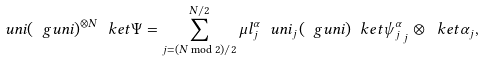<formula> <loc_0><loc_0><loc_500><loc_500>\ u n i ( \ g u n i ) ^ { \otimes N } \ k e t { \Psi } = \sum _ { j = ( N \bmod 2 ) / 2 } ^ { N / 2 } \mu l _ { j } ^ { \alpha } \ u n i _ { j } ( \ g u n i ) \ k e t { \psi _ { j } ^ { \alpha } } _ { j } \otimes \ k e t { \alpha } _ { j } ,</formula> 